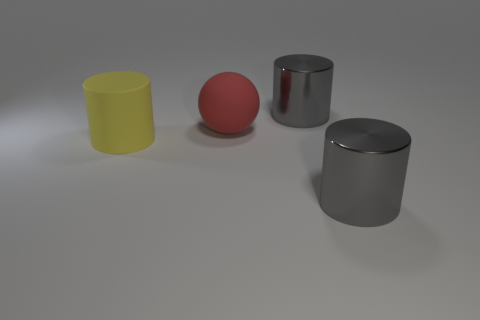Add 3 big rubber objects. How many objects exist? 7 Subtract all balls. How many objects are left? 3 Add 3 red spheres. How many red spheres are left? 4 Add 2 large red matte balls. How many large red matte balls exist? 3 Subtract 0 purple blocks. How many objects are left? 4 Subtract all blue balls. Subtract all large red balls. How many objects are left? 3 